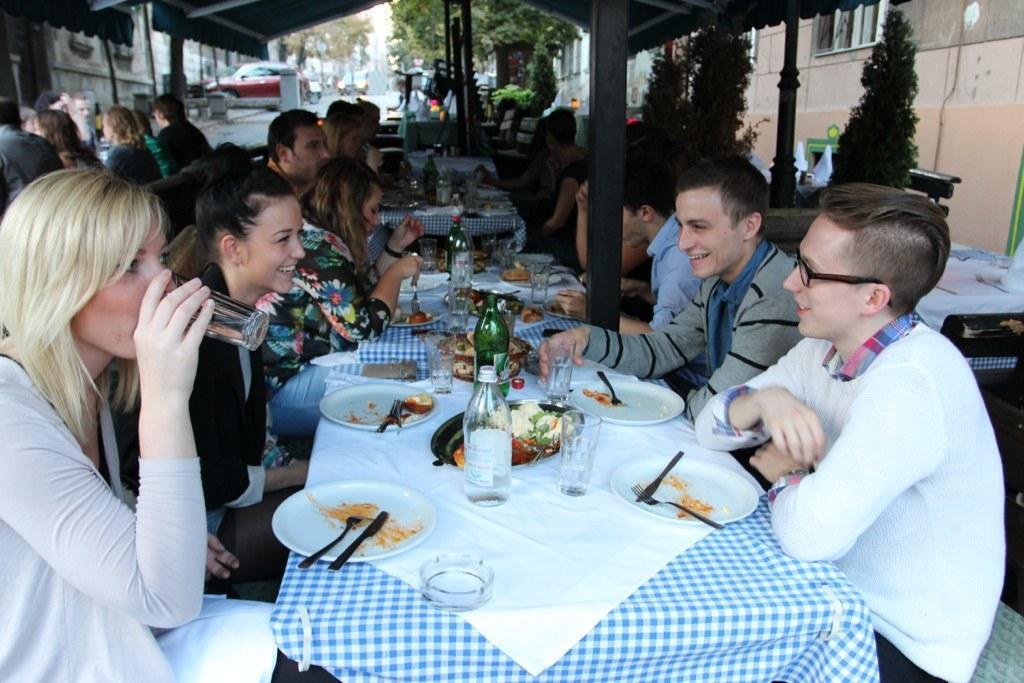Can you describe this image briefly? In this image we can see many people sitting around the table. There are few plates with food, bottles, glasses and a table cloth placed on the table. In the background we can see a car, trees and a building. 